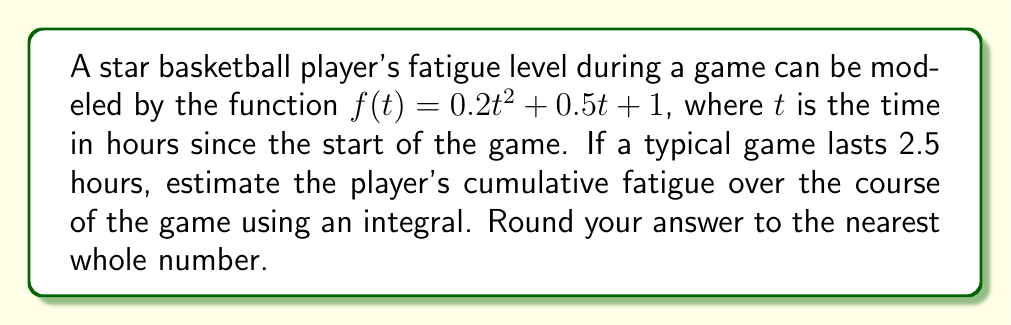Show me your answer to this math problem. To estimate the player's cumulative fatigue over the course of the game, we need to calculate the area under the fatigue function $f(t)$ from $t=0$ to $t=2.5$ hours. This can be done using a definite integral.

Step 1: Set up the integral
$$\int_{0}^{2.5} (0.2t^2 + 0.5t + 1) dt$$

Step 2: Integrate the function
$$\left[\frac{0.2t^3}{3} + \frac{0.5t^2}{2} + t\right]_{0}^{2.5}$$

Step 3: Evaluate the integral at the upper and lower bounds
Upper bound (t = 2.5):
$$\frac{0.2(2.5)^3}{3} + \frac{0.5(2.5)^2}{2} + 2.5 = \frac{3.125}{3} + 1.5625 + 2.5 = 5.2083$$

Lower bound (t = 0):
$$\frac{0.2(0)^3}{3} + \frac{0.5(0)^2}{2} + 0 = 0$$

Step 4: Subtract the lower bound from the upper bound
$$5.2083 - 0 = 5.2083$$

Step 5: Round to the nearest whole number
$$5.2083 \approx 5$$

Therefore, the estimated cumulative fatigue over the course of the game is 5 fatigue units.
Answer: 5 fatigue units 